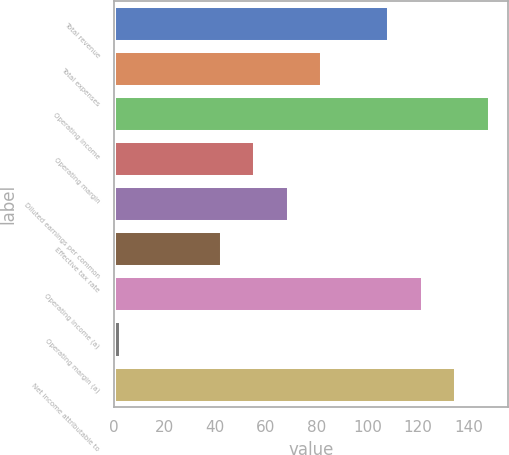Convert chart to OTSL. <chart><loc_0><loc_0><loc_500><loc_500><bar_chart><fcel>Total revenue<fcel>Total expenses<fcel>Operating income<fcel>Operating margin<fcel>Diluted earnings per common<fcel>Effective tax rate<fcel>Operating income (a)<fcel>Operating margin (a)<fcel>Net income attributable to<nl><fcel>108.6<fcel>82.2<fcel>148.2<fcel>55.8<fcel>69<fcel>42.6<fcel>121.8<fcel>3<fcel>135<nl></chart> 